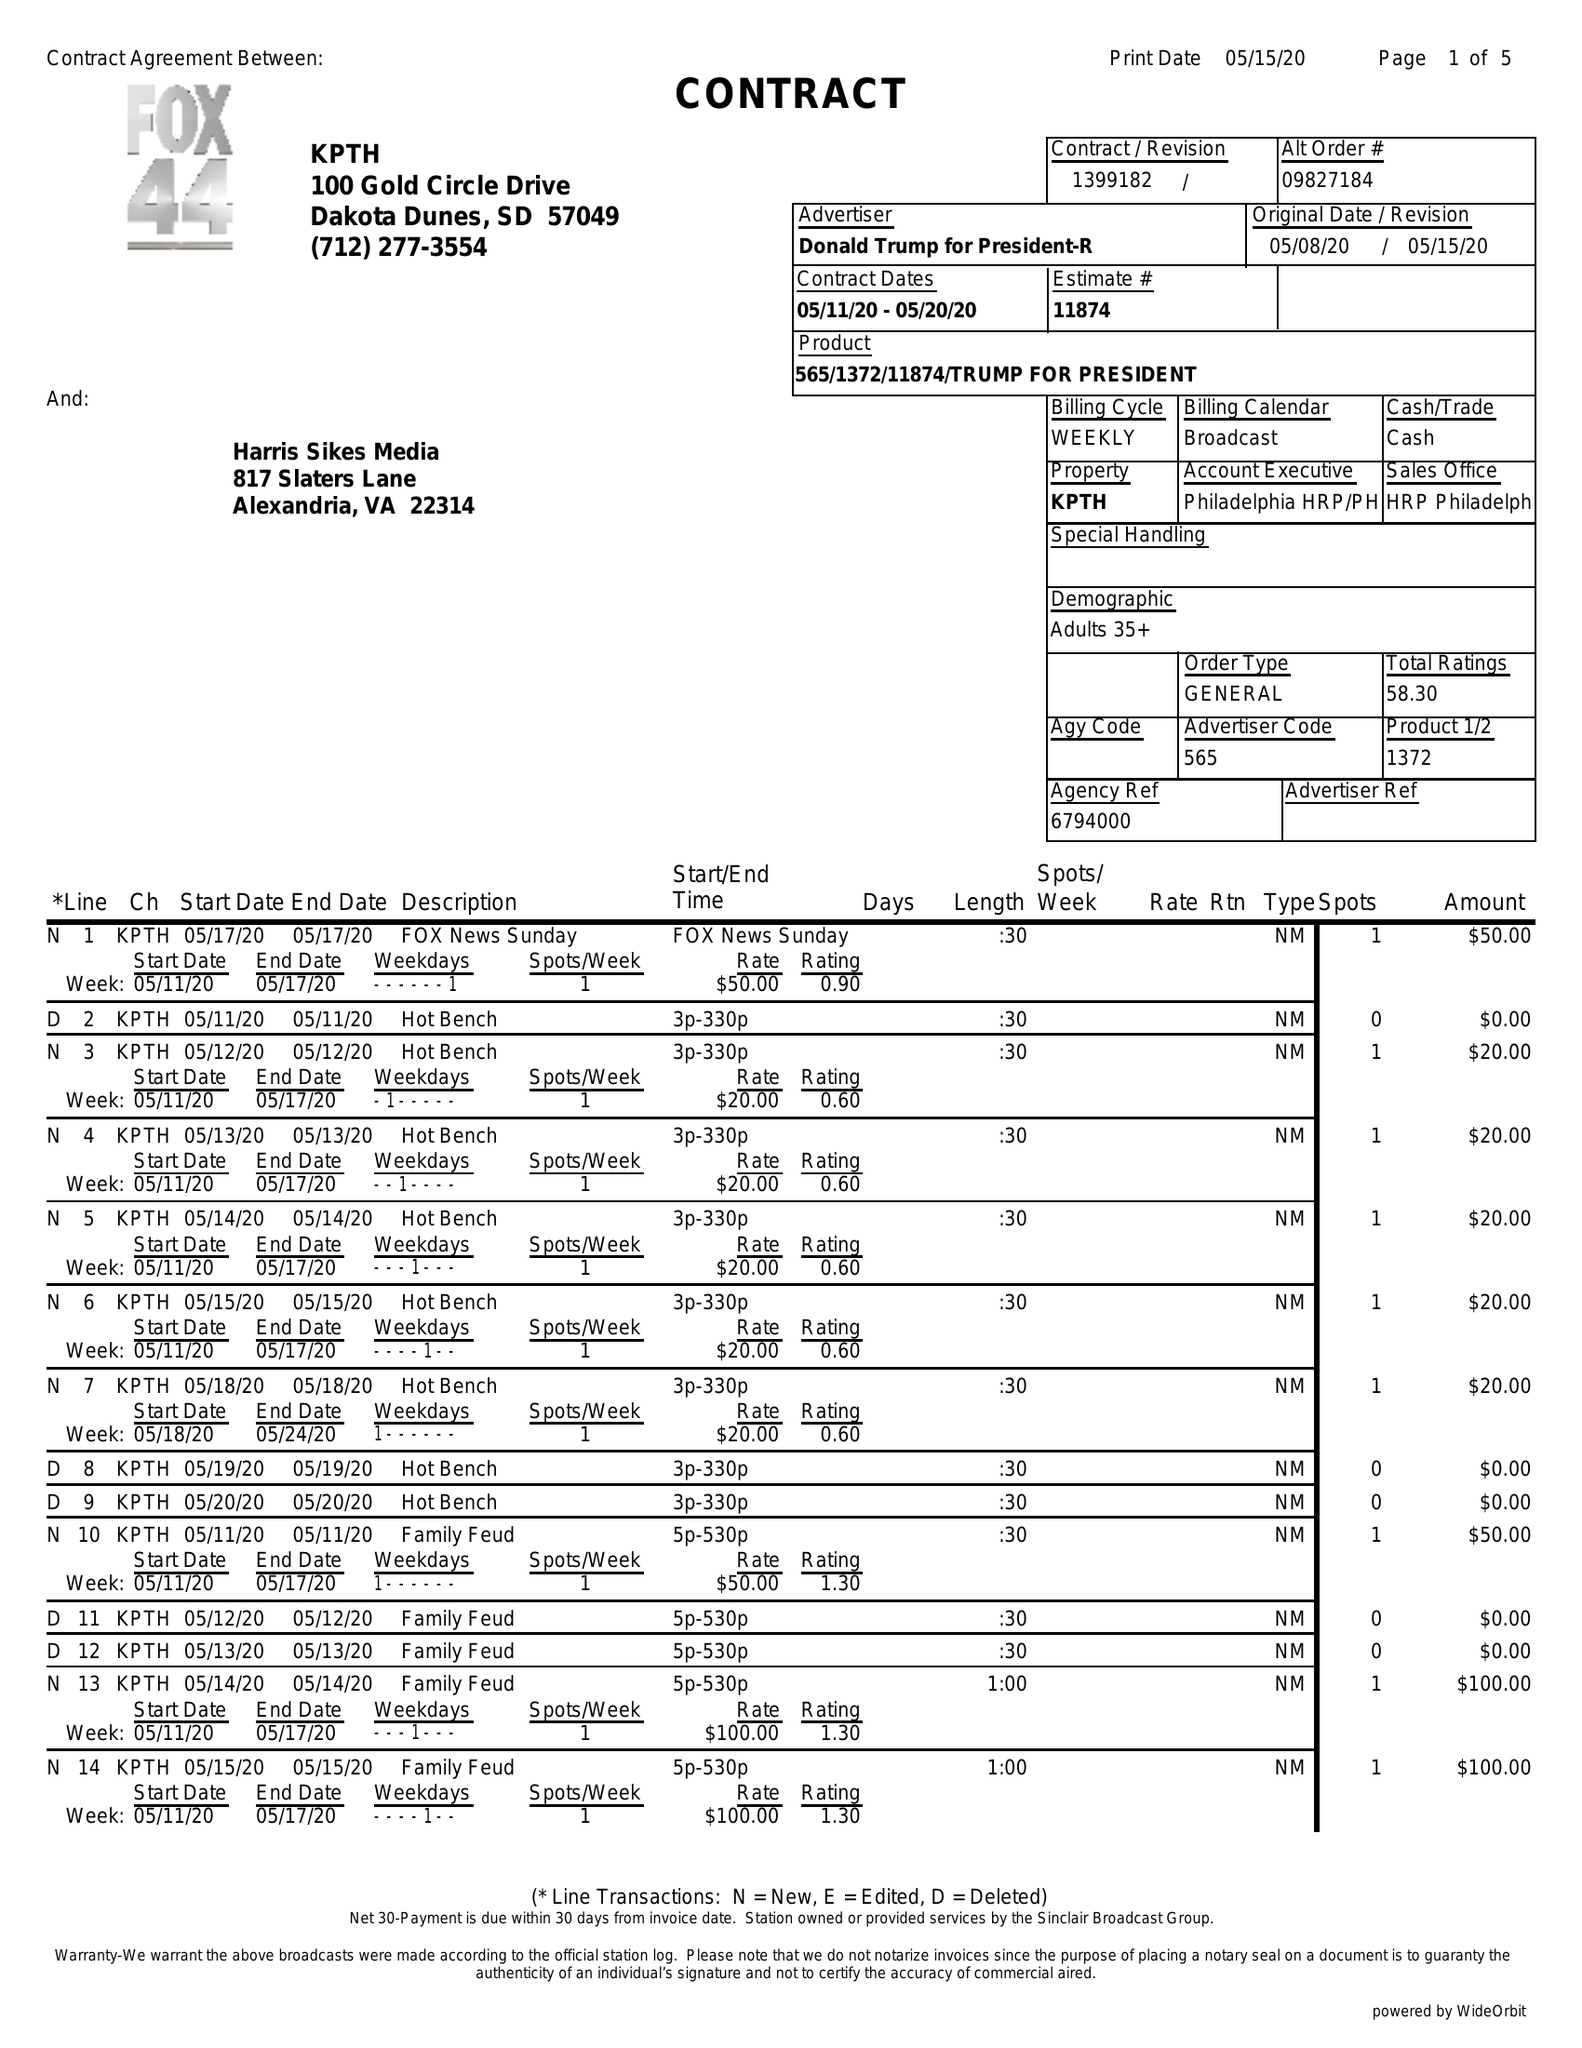What is the value for the advertiser?
Answer the question using a single word or phrase. DONALD TRUMP FOR PRESIDENT-R 